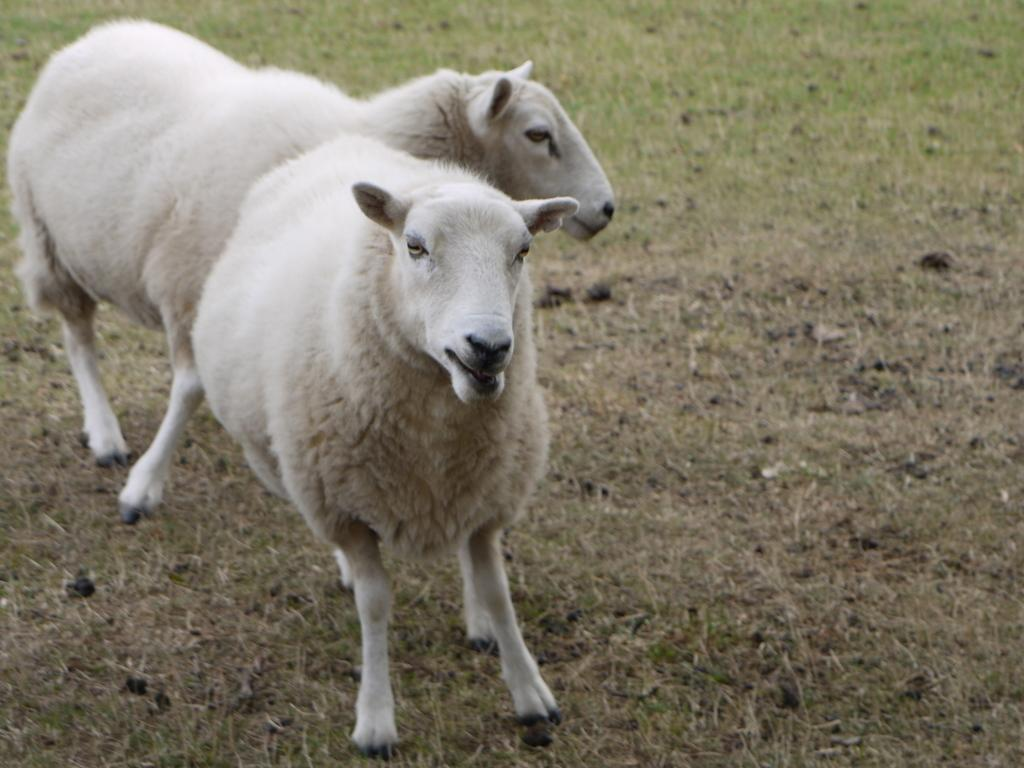What animals are present in the image? There are two white color sheep in the image. What is the position of the sheep in the image? The sheep are on the ground. What type of vegetation is on the ground in the image? There is grass on the ground in the image. What is the texture of the geese in the image? There are no geese present in the image; it features two white color sheep. What type of reward is the sheep receiving in the image? There is no indication in the image that the sheep are receiving any reward. 